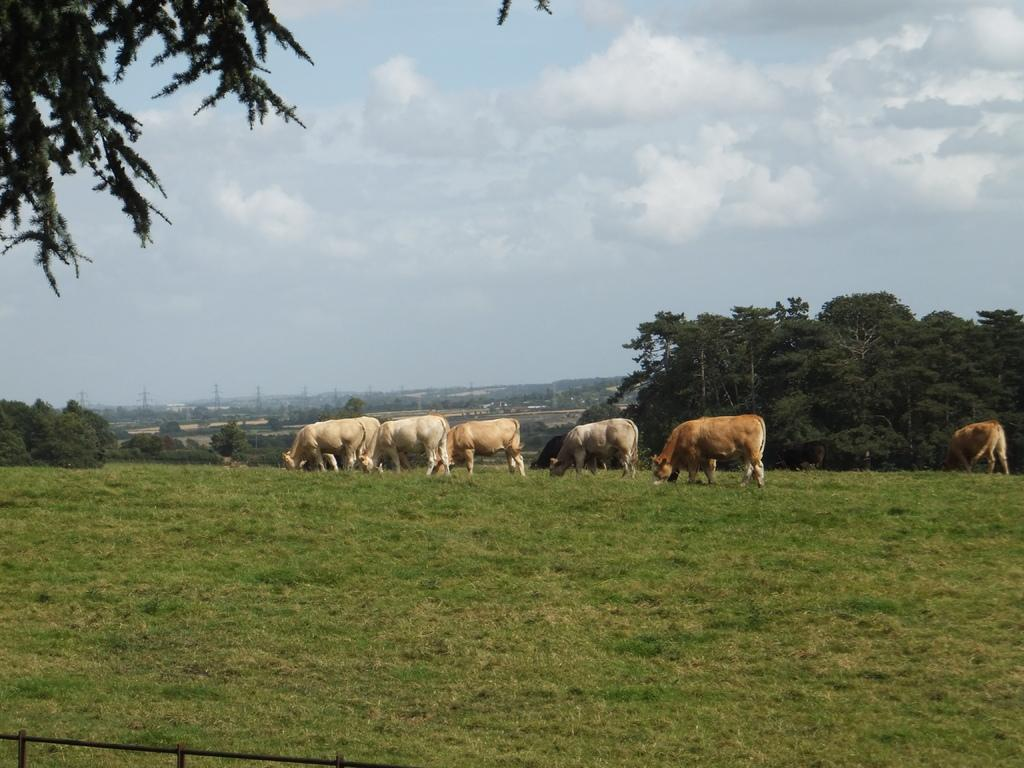What animals can be seen on the ground in the image? There are cows on the ground in the image. What type of vegetation covers the ground? The ground is covered in grass. What other types of vegetation are present in the image? There are plants and trees in the image. What can be seen in the background of the image? The sky is visible in the background. What is the condition of the sky in the image? Clouds are present in the sky. How many chickens are sitting on the horn in the image? There are no chickens or horns present in the image. 